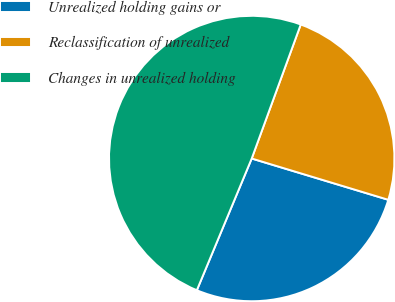Convert chart to OTSL. <chart><loc_0><loc_0><loc_500><loc_500><pie_chart><fcel>Unrealized holding gains or<fcel>Reclassification of unrealized<fcel>Changes in unrealized holding<nl><fcel>26.61%<fcel>24.09%<fcel>49.3%<nl></chart> 